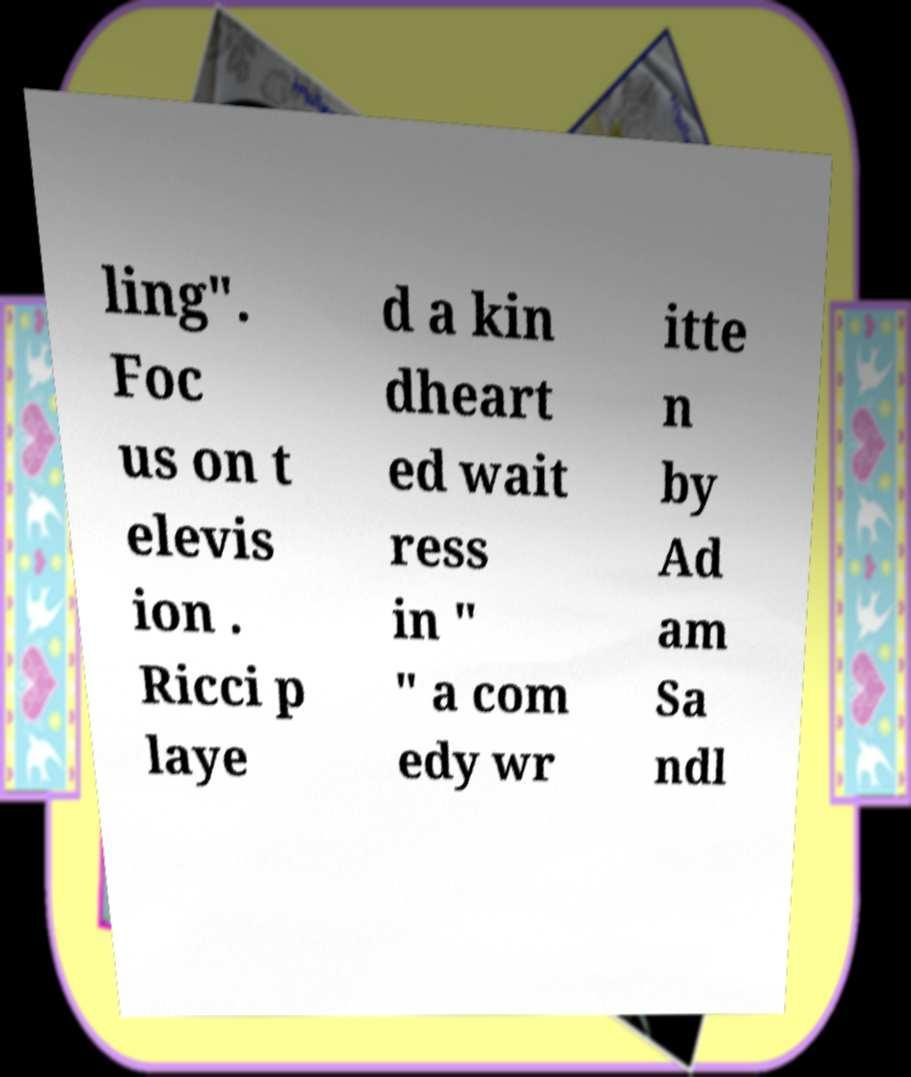Please identify and transcribe the text found in this image. ling". Foc us on t elevis ion . Ricci p laye d a kin dheart ed wait ress in " " a com edy wr itte n by Ad am Sa ndl 